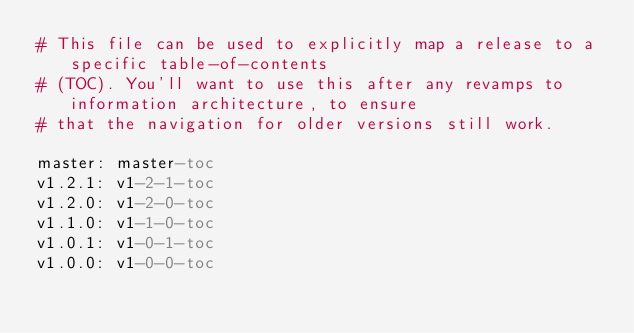Convert code to text. <code><loc_0><loc_0><loc_500><loc_500><_YAML_># This file can be used to explicitly map a release to a specific table-of-contents
# (TOC). You'll want to use this after any revamps to information architecture, to ensure
# that the navigation for older versions still work.

master: master-toc
v1.2.1: v1-2-1-toc
v1.2.0: v1-2-0-toc
v1.1.0: v1-1-0-toc
v1.0.1: v1-0-1-toc
v1.0.0: v1-0-0-toc

</code> 